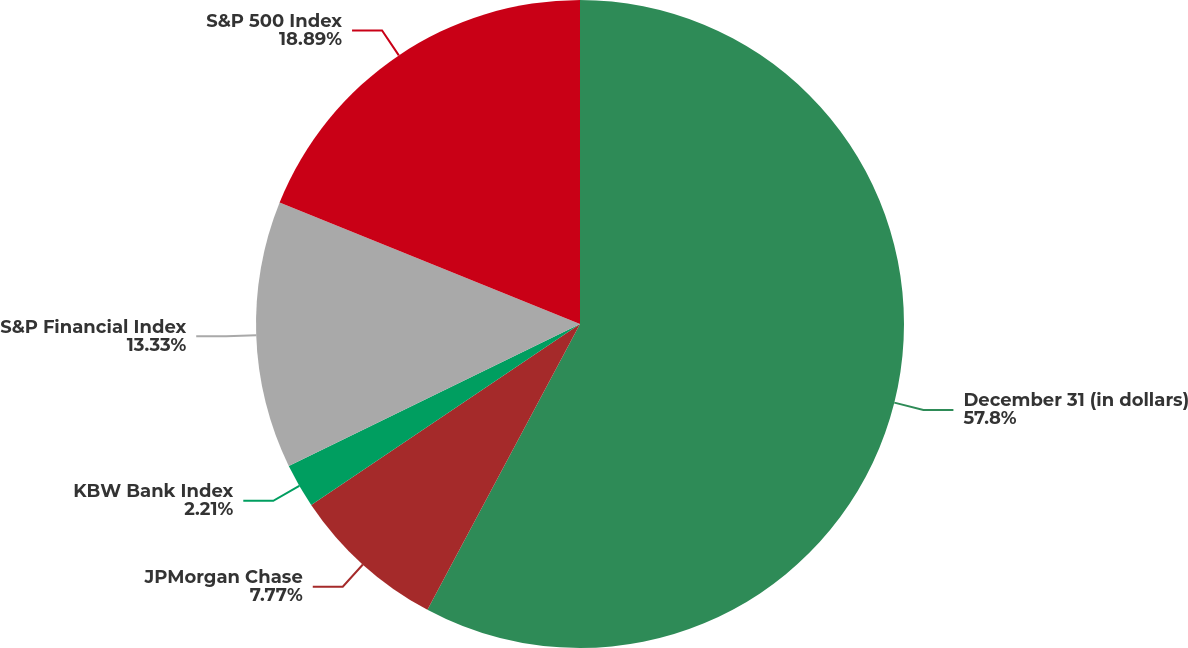<chart> <loc_0><loc_0><loc_500><loc_500><pie_chart><fcel>December 31 (in dollars)<fcel>JPMorgan Chase<fcel>KBW Bank Index<fcel>S&P Financial Index<fcel>S&P 500 Index<nl><fcel>57.81%<fcel>7.77%<fcel>2.21%<fcel>13.33%<fcel>18.89%<nl></chart> 